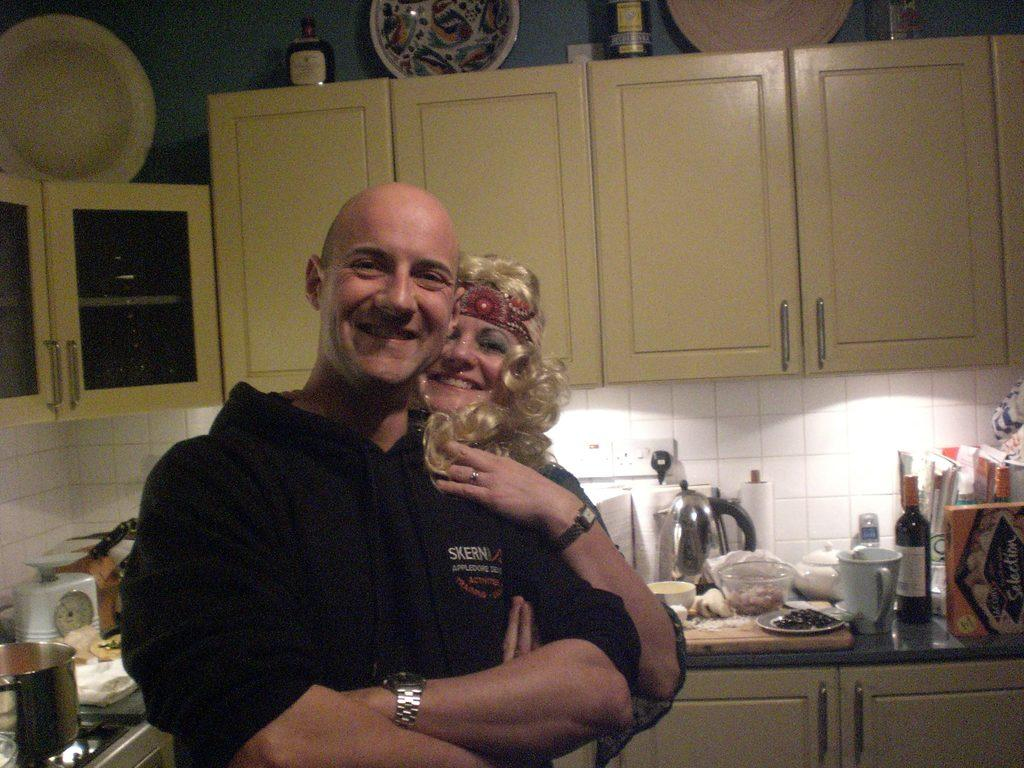How many people are in the image? There are two people in the image, a man and a woman. Where are the individuals located in the image? Both individuals are standing in a kitchen. What can be seen in the background of the image? There is a cupboard in the background of the image. What is on top of the cupboard? There are items on the cupboard. What type of tail can be seen on the manager in the image? There is no manager present in the image, and therefore no tail can be seen. 